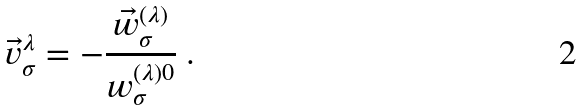<formula> <loc_0><loc_0><loc_500><loc_500>\vec { v } _ { \sigma } ^ { \lambda } = - \frac { \vec { w } ^ { ( \lambda ) } _ { \sigma } } { w ^ { ( \lambda ) 0 } _ { \sigma } } \ .</formula> 